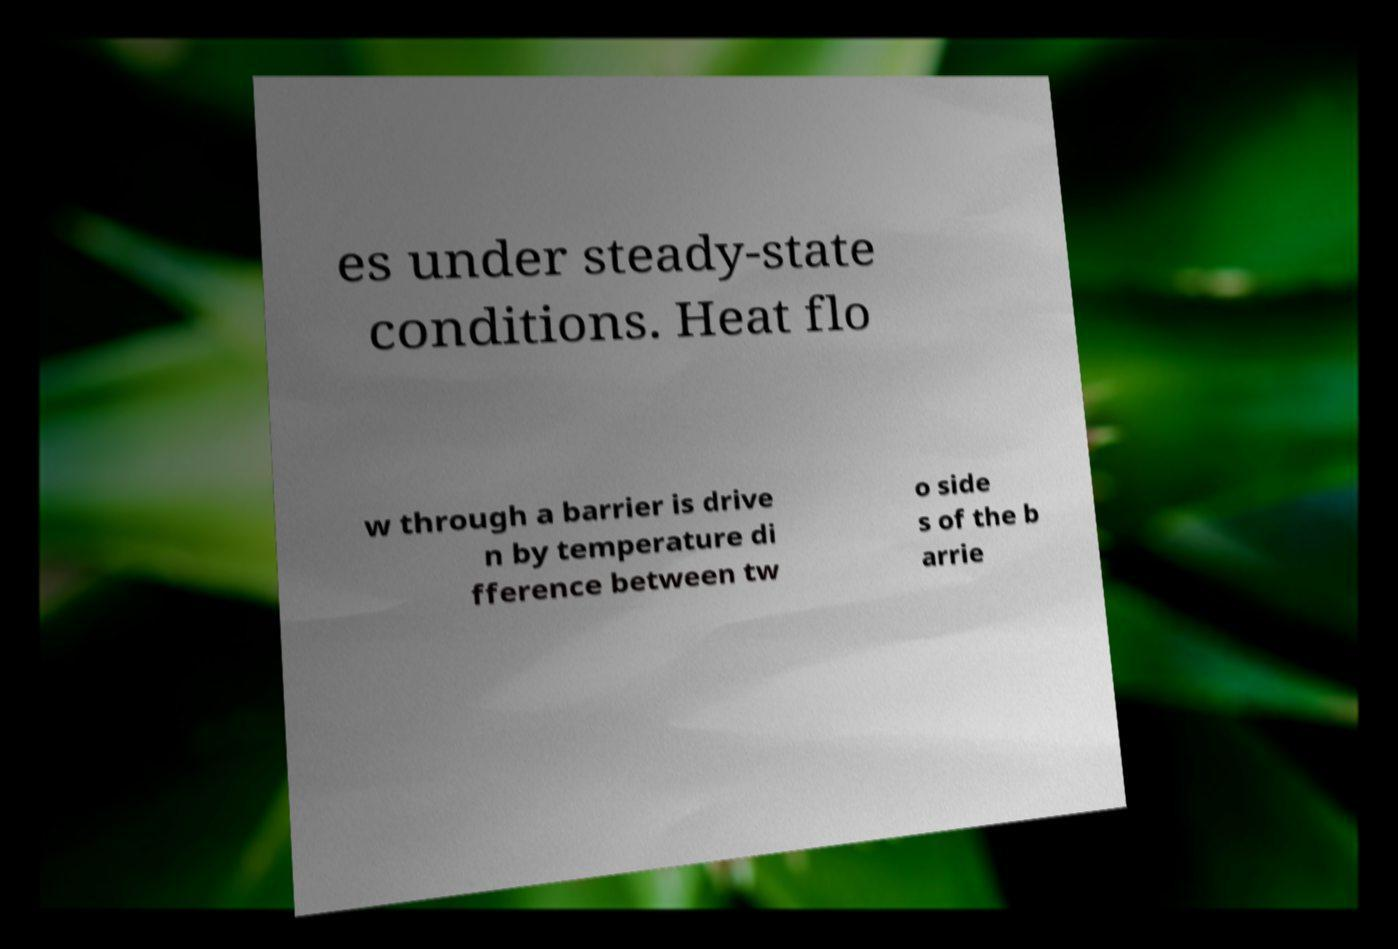I need the written content from this picture converted into text. Can you do that? es under steady-state conditions. Heat flo w through a barrier is drive n by temperature di fference between tw o side s of the b arrie 